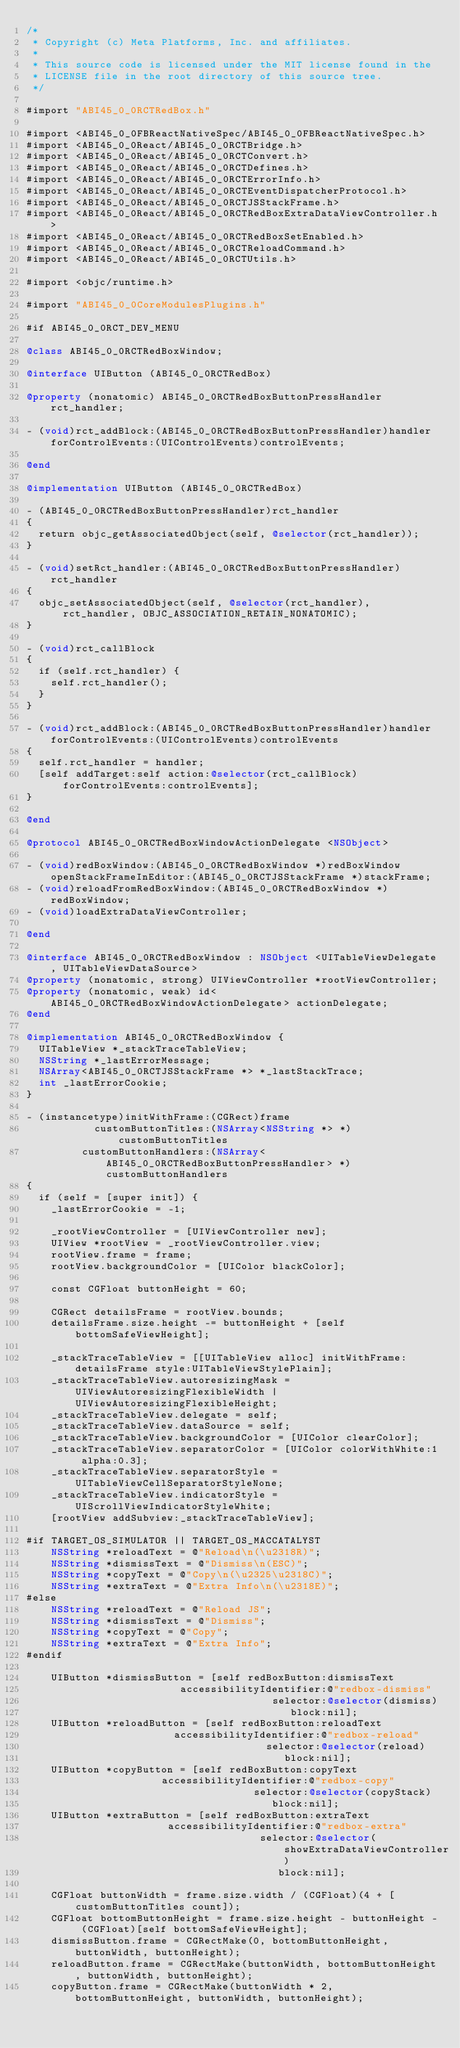Convert code to text. <code><loc_0><loc_0><loc_500><loc_500><_ObjectiveC_>/*
 * Copyright (c) Meta Platforms, Inc. and affiliates.
 *
 * This source code is licensed under the MIT license found in the
 * LICENSE file in the root directory of this source tree.
 */

#import "ABI45_0_0RCTRedBox.h"

#import <ABI45_0_0FBReactNativeSpec/ABI45_0_0FBReactNativeSpec.h>
#import <ABI45_0_0React/ABI45_0_0RCTBridge.h>
#import <ABI45_0_0React/ABI45_0_0RCTConvert.h>
#import <ABI45_0_0React/ABI45_0_0RCTDefines.h>
#import <ABI45_0_0React/ABI45_0_0RCTErrorInfo.h>
#import <ABI45_0_0React/ABI45_0_0RCTEventDispatcherProtocol.h>
#import <ABI45_0_0React/ABI45_0_0RCTJSStackFrame.h>
#import <ABI45_0_0React/ABI45_0_0RCTRedBoxExtraDataViewController.h>
#import <ABI45_0_0React/ABI45_0_0RCTRedBoxSetEnabled.h>
#import <ABI45_0_0React/ABI45_0_0RCTReloadCommand.h>
#import <ABI45_0_0React/ABI45_0_0RCTUtils.h>

#import <objc/runtime.h>

#import "ABI45_0_0CoreModulesPlugins.h"

#if ABI45_0_0RCT_DEV_MENU

@class ABI45_0_0RCTRedBoxWindow;

@interface UIButton (ABI45_0_0RCTRedBox)

@property (nonatomic) ABI45_0_0RCTRedBoxButtonPressHandler rct_handler;

- (void)rct_addBlock:(ABI45_0_0RCTRedBoxButtonPressHandler)handler forControlEvents:(UIControlEvents)controlEvents;

@end

@implementation UIButton (ABI45_0_0RCTRedBox)

- (ABI45_0_0RCTRedBoxButtonPressHandler)rct_handler
{
  return objc_getAssociatedObject(self, @selector(rct_handler));
}

- (void)setRct_handler:(ABI45_0_0RCTRedBoxButtonPressHandler)rct_handler
{
  objc_setAssociatedObject(self, @selector(rct_handler), rct_handler, OBJC_ASSOCIATION_RETAIN_NONATOMIC);
}

- (void)rct_callBlock
{
  if (self.rct_handler) {
    self.rct_handler();
  }
}

- (void)rct_addBlock:(ABI45_0_0RCTRedBoxButtonPressHandler)handler forControlEvents:(UIControlEvents)controlEvents
{
  self.rct_handler = handler;
  [self addTarget:self action:@selector(rct_callBlock) forControlEvents:controlEvents];
}

@end

@protocol ABI45_0_0RCTRedBoxWindowActionDelegate <NSObject>

- (void)redBoxWindow:(ABI45_0_0RCTRedBoxWindow *)redBoxWindow openStackFrameInEditor:(ABI45_0_0RCTJSStackFrame *)stackFrame;
- (void)reloadFromRedBoxWindow:(ABI45_0_0RCTRedBoxWindow *)redBoxWindow;
- (void)loadExtraDataViewController;

@end

@interface ABI45_0_0RCTRedBoxWindow : NSObject <UITableViewDelegate, UITableViewDataSource>
@property (nonatomic, strong) UIViewController *rootViewController;
@property (nonatomic, weak) id<ABI45_0_0RCTRedBoxWindowActionDelegate> actionDelegate;
@end

@implementation ABI45_0_0RCTRedBoxWindow {
  UITableView *_stackTraceTableView;
  NSString *_lastErrorMessage;
  NSArray<ABI45_0_0RCTJSStackFrame *> *_lastStackTrace;
  int _lastErrorCookie;
}

- (instancetype)initWithFrame:(CGRect)frame
           customButtonTitles:(NSArray<NSString *> *)customButtonTitles
         customButtonHandlers:(NSArray<ABI45_0_0RCTRedBoxButtonPressHandler> *)customButtonHandlers
{
  if (self = [super init]) {
    _lastErrorCookie = -1;

    _rootViewController = [UIViewController new];
    UIView *rootView = _rootViewController.view;
    rootView.frame = frame;
    rootView.backgroundColor = [UIColor blackColor];

    const CGFloat buttonHeight = 60;

    CGRect detailsFrame = rootView.bounds;
    detailsFrame.size.height -= buttonHeight + [self bottomSafeViewHeight];

    _stackTraceTableView = [[UITableView alloc] initWithFrame:detailsFrame style:UITableViewStylePlain];
    _stackTraceTableView.autoresizingMask = UIViewAutoresizingFlexibleWidth | UIViewAutoresizingFlexibleHeight;
    _stackTraceTableView.delegate = self;
    _stackTraceTableView.dataSource = self;
    _stackTraceTableView.backgroundColor = [UIColor clearColor];
    _stackTraceTableView.separatorColor = [UIColor colorWithWhite:1 alpha:0.3];
    _stackTraceTableView.separatorStyle = UITableViewCellSeparatorStyleNone;
    _stackTraceTableView.indicatorStyle = UIScrollViewIndicatorStyleWhite;
    [rootView addSubview:_stackTraceTableView];

#if TARGET_OS_SIMULATOR || TARGET_OS_MACCATALYST
    NSString *reloadText = @"Reload\n(\u2318R)";
    NSString *dismissText = @"Dismiss\n(ESC)";
    NSString *copyText = @"Copy\n(\u2325\u2318C)";
    NSString *extraText = @"Extra Info\n(\u2318E)";
#else
    NSString *reloadText = @"Reload JS";
    NSString *dismissText = @"Dismiss";
    NSString *copyText = @"Copy";
    NSString *extraText = @"Extra Info";
#endif

    UIButton *dismissButton = [self redBoxButton:dismissText
                         accessibilityIdentifier:@"redbox-dismiss"
                                        selector:@selector(dismiss)
                                           block:nil];
    UIButton *reloadButton = [self redBoxButton:reloadText
                        accessibilityIdentifier:@"redbox-reload"
                                       selector:@selector(reload)
                                          block:nil];
    UIButton *copyButton = [self redBoxButton:copyText
                      accessibilityIdentifier:@"redbox-copy"
                                     selector:@selector(copyStack)
                                        block:nil];
    UIButton *extraButton = [self redBoxButton:extraText
                       accessibilityIdentifier:@"redbox-extra"
                                      selector:@selector(showExtraDataViewController)
                                         block:nil];

    CGFloat buttonWidth = frame.size.width / (CGFloat)(4 + [customButtonTitles count]);
    CGFloat bottomButtonHeight = frame.size.height - buttonHeight - (CGFloat)[self bottomSafeViewHeight];
    dismissButton.frame = CGRectMake(0, bottomButtonHeight, buttonWidth, buttonHeight);
    reloadButton.frame = CGRectMake(buttonWidth, bottomButtonHeight, buttonWidth, buttonHeight);
    copyButton.frame = CGRectMake(buttonWidth * 2, bottomButtonHeight, buttonWidth, buttonHeight);</code> 